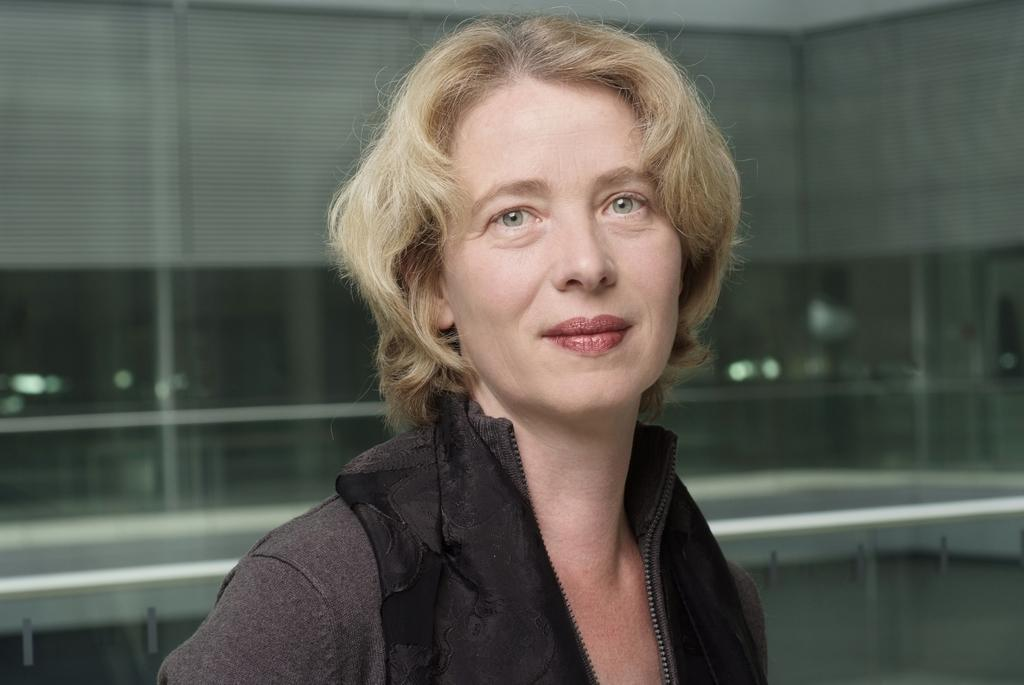Who is the main subject in the foreground of the picture? There is a woman in the foreground of the picture. What is the woman wearing in the image? The woman is wearing a brown jacket. What can be seen in the background of the picture? There is a glass window in the background of the picture. Are there any window treatments visible in the image? Yes, window blinds are present on the glass window. What type of event is taking place in the image? There is no indication of an event taking place in the image; it simply shows a woman in the foreground and a glass window with window blinds in the background. How many men are visible in the image? There are no men visible in the image; it only features a woman in the foreground. 